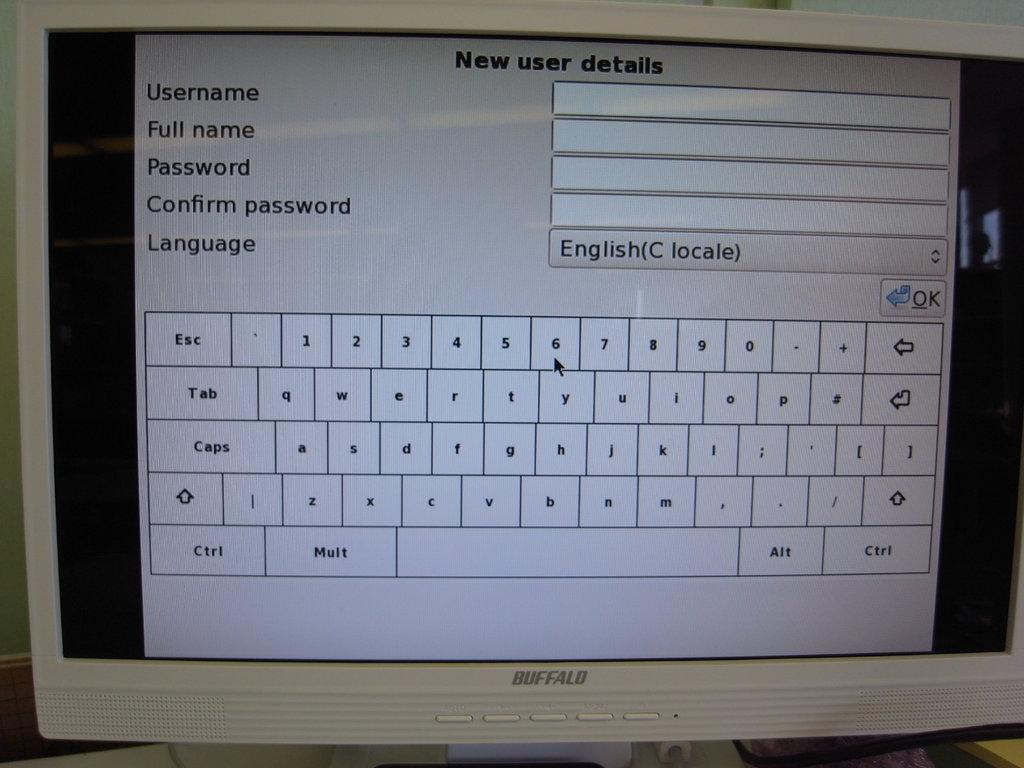What is the main object in the image? There is a monitor screen in the image. Can you describe the monitor screen in more detail? Unfortunately, the provided facts do not offer any additional details about the monitor screen. Is there a tiger wearing a mitten on the monitor screen in the image? There is no tiger or mitten present on the monitor screen in the image. 